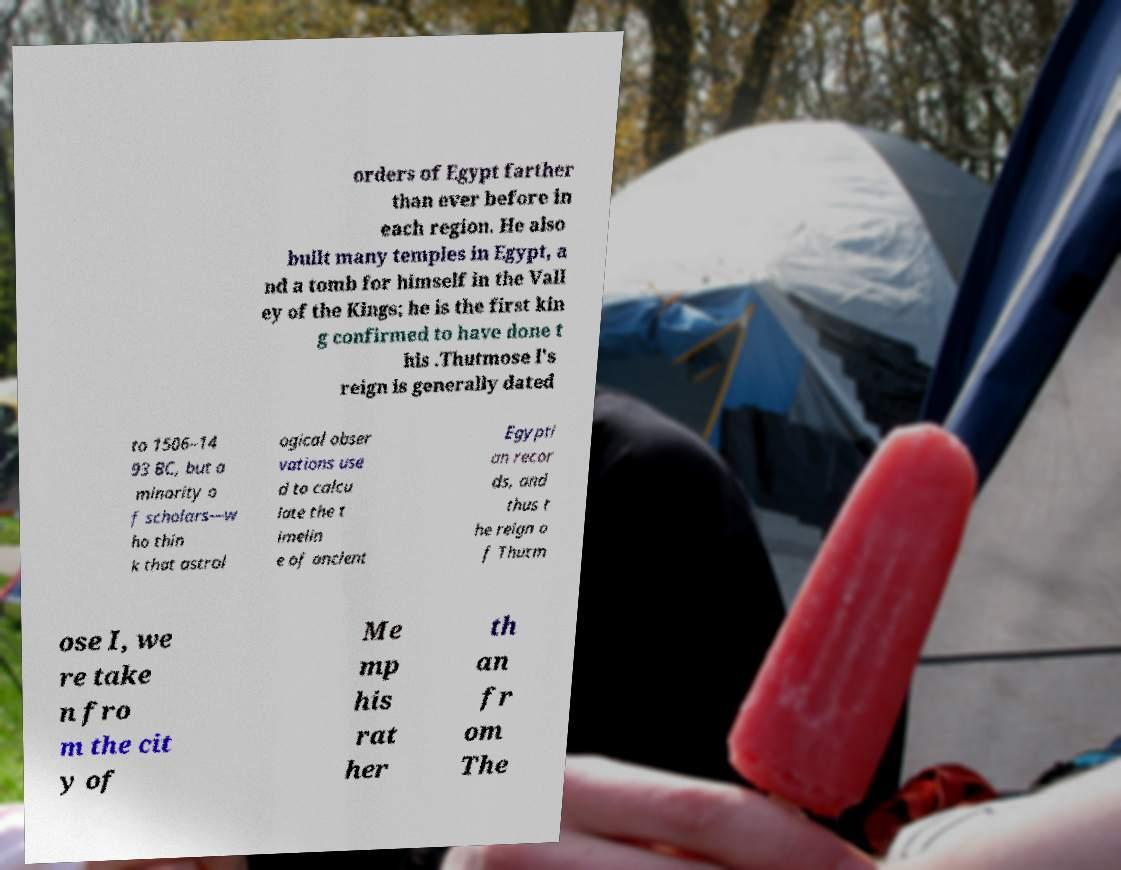I need the written content from this picture converted into text. Can you do that? orders of Egypt farther than ever before in each region. He also built many temples in Egypt, a nd a tomb for himself in the Vall ey of the Kings; he is the first kin g confirmed to have done t his .Thutmose I's reign is generally dated to 1506–14 93 BC, but a minority o f scholars—w ho thin k that astrol ogical obser vations use d to calcu late the t imelin e of ancient Egypti an recor ds, and thus t he reign o f Thutm ose I, we re take n fro m the cit y of Me mp his rat her th an fr om The 